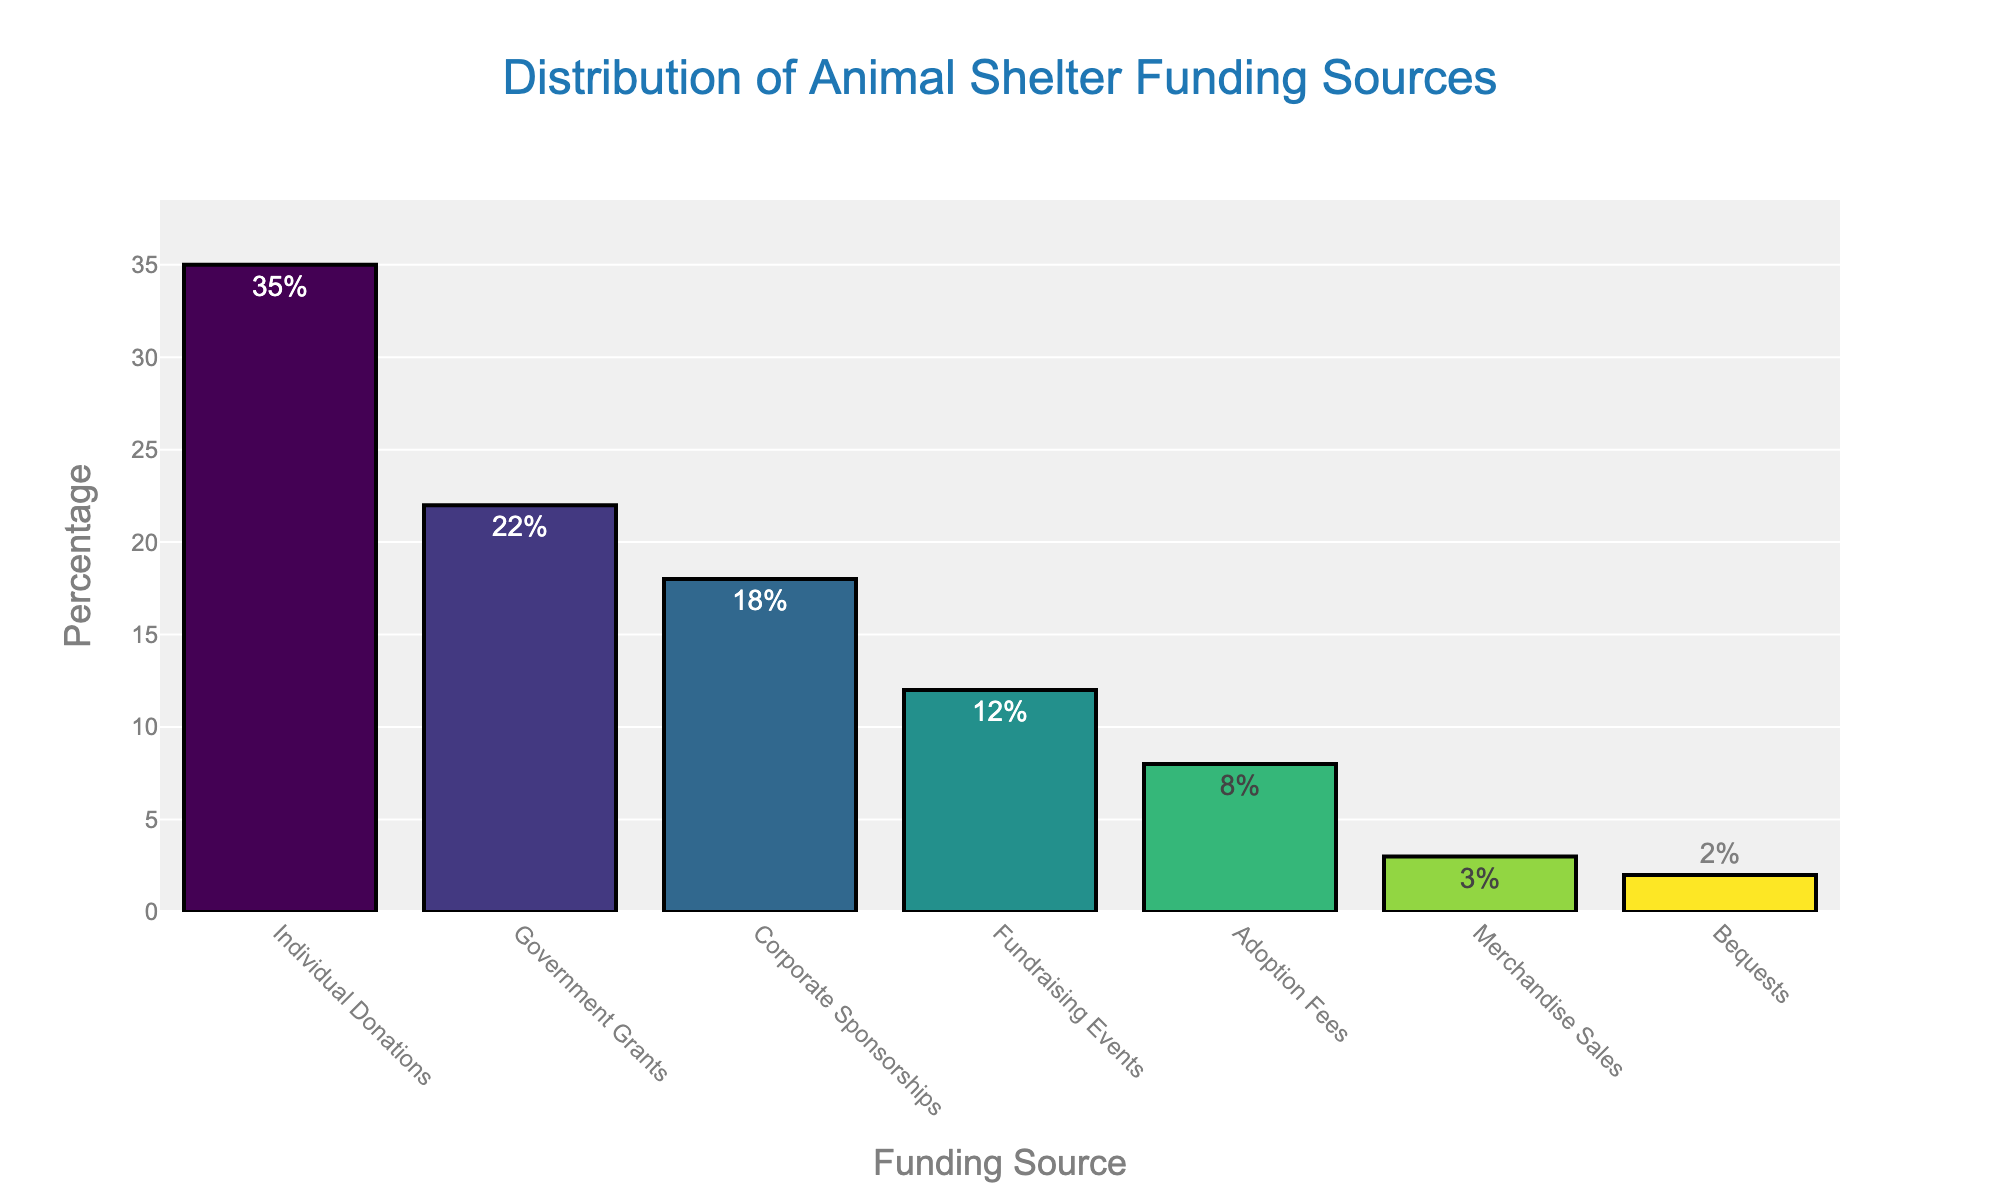Which funding source contributes the highest percentage to the animal shelter? First, scan the bars to identify the tallest one. The label on the tallest bar indicates the funding source with the highest contribution. According to the chart, the highest percentage is contributed by Individual Donations at 35%.
Answer: Individual Donations What is the total percentage contributed by Individual Donations, Corporate Sponsorships, and Fundraising Events combined? Sum the percentages of Individual Donations (35%), Corporate Sponsorships (18%), and Fundraising Events (12%). The calculation is 35 + 18 + 12 = 65%.
Answer: 65% Which funding source contributes the least to the animal shelter? Identify the shortest bar in the chart. The label on this bar indicates the funding source with the smallest contribution. According to the chart, the smallest contribution is from Bequests at 2%.
Answer: Bequests How much higher is the percentage of Adoption Fees compared to Merchandise Sales? Subtract the percentage of Merchandise Sales (3%) from the percentage of Adoption Fees (8%). The calculation is 8 - 3 = 5%.
Answer: 5% Is the percentage from Government Grants higher or lower than that from Corporate Sponsorships, and by how much? Compare the percentage values of Government Grants (22%) and Corporate Sponsorships (18%). Government Grants is higher. Subtract 18 from 22 to find the difference. The calculation is 22 - 18 = 4%.
Answer: Higher by 4% What is the combined percentage of sources contributing less than 10% each? Identify the sources that contribute less than 10%: Adoption Fees (8%), Merchandise Sales (3%), and Bequests (2%). Sum their percentages: 8 + 3 + 2 = 13%.
Answer: 13% Which is greater, the sum of percentages from Individual Donations and Government Grants, or the sum from Corporate Sponsorships, Fundraising Events, and Adoption Fees? First, calculate the sum of Individual Donations and Government Grants: 35 + 22 = 57%. Then, calculate the sum of Corporate Sponsorships, Fundraising Events, and Adoption Fees: 18 + 12 + 8 = 38%. Compare the two sums.
Answer: Sum of Individual Donations and Government Grants How does the percentage of Government Grants compare to the percentage of Fundraising Events? Compare the heights of the bars corresponding to Government Grants (22%) and Fundraising Events (12%). Government Grants is higher.
Answer: Government Grants is higher 